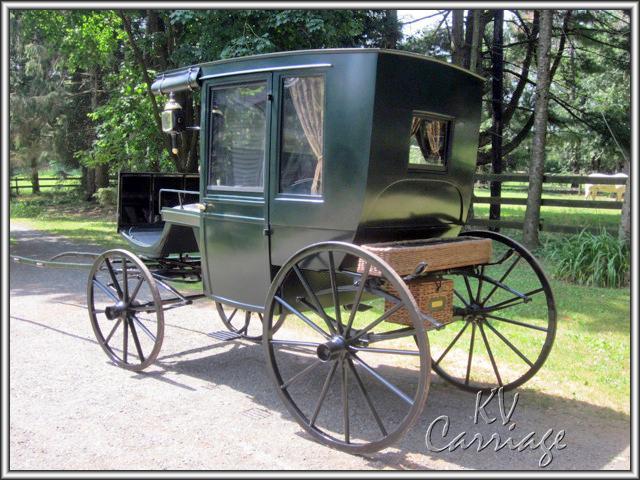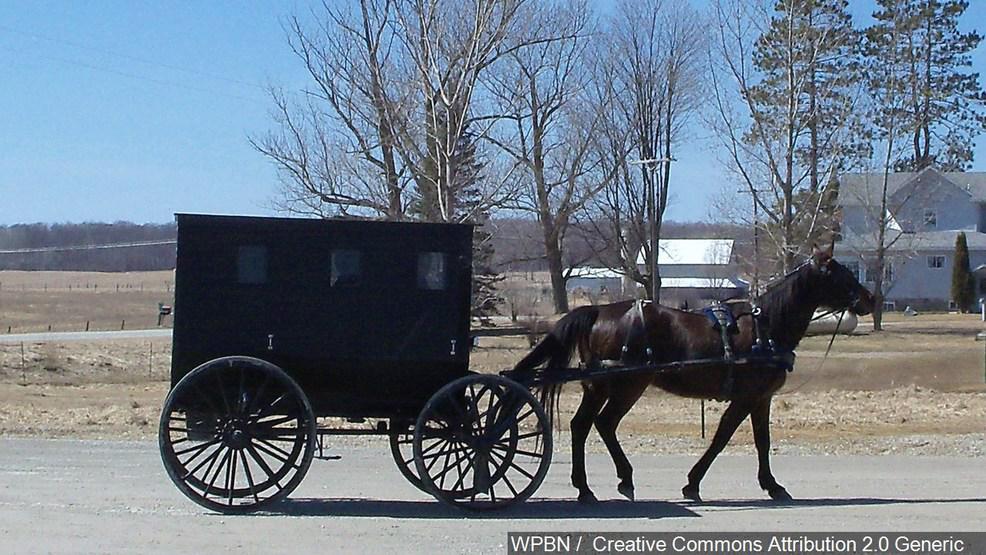The first image is the image on the left, the second image is the image on the right. For the images shown, is this caption "The left image shows a carriage but no horses." true? Answer yes or no. Yes. The first image is the image on the left, the second image is the image on the right. For the images displayed, is the sentence "Five or fewer mammals are visible." factually correct? Answer yes or no. Yes. 